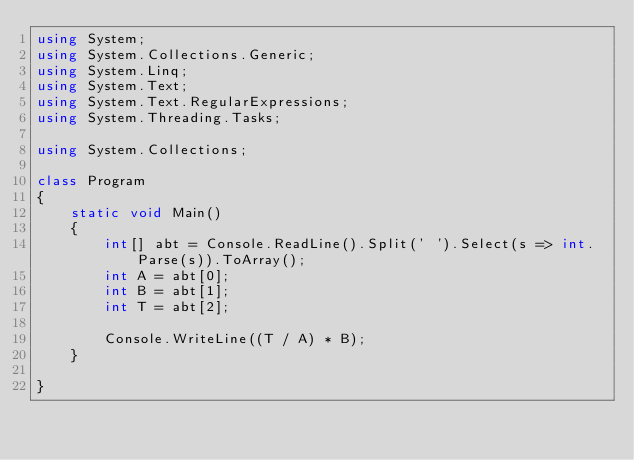Convert code to text. <code><loc_0><loc_0><loc_500><loc_500><_C#_>using System;
using System.Collections.Generic;
using System.Linq;
using System.Text;
using System.Text.RegularExpressions;
using System.Threading.Tasks;

using System.Collections;

class Program
{
    static void Main()
    {
        int[] abt = Console.ReadLine().Split(' ').Select(s => int.Parse(s)).ToArray();
        int A = abt[0];
        int B = abt[1];
        int T = abt[2];

        Console.WriteLine((T / A) * B);
    }
    
}
</code> 